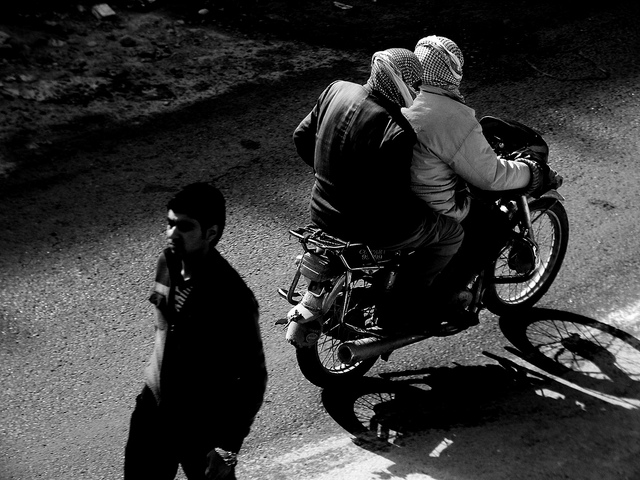Can you describe the environment in which the motorcycle is being ridden? The motorcycle is being ridden on what appears to be an urban street, indicated by the asphalt road and the presence of a pedestrian. The clarity of the shadows and the lack of traffic suggest a quiet moment in an otherwise potentially busy area. 